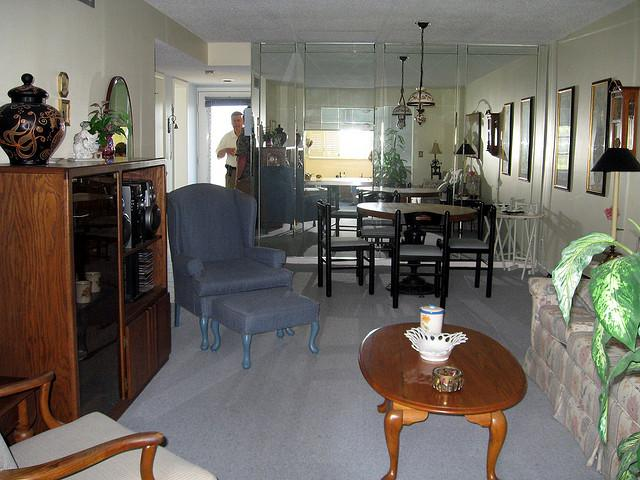What color is the vase in the middle of the coffee table? white 